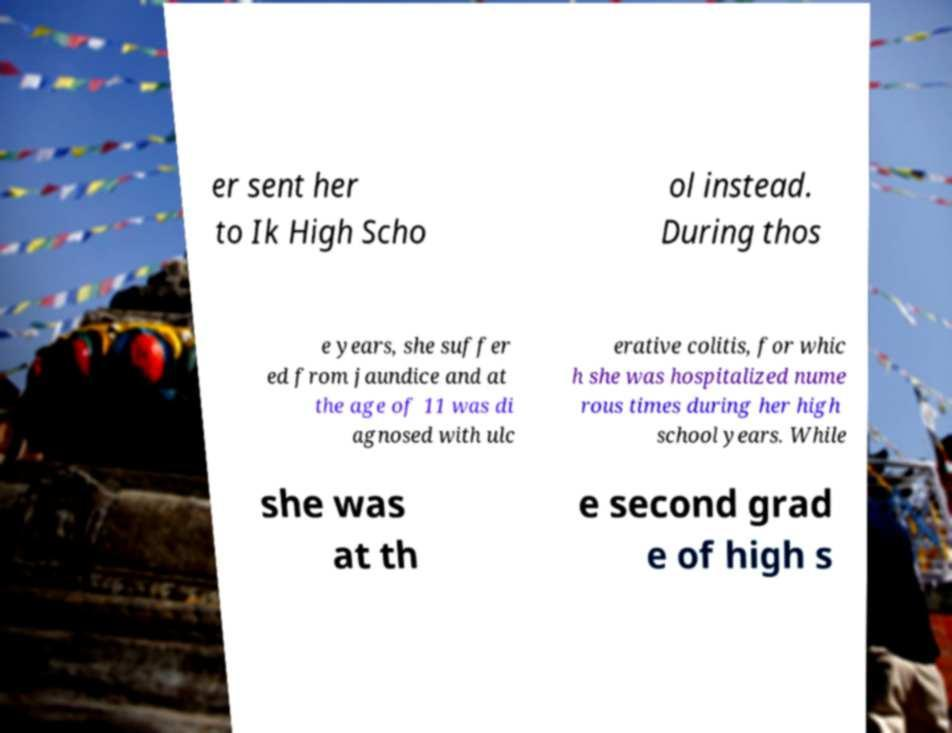What messages or text are displayed in this image? I need them in a readable, typed format. er sent her to Ik High Scho ol instead. During thos e years, she suffer ed from jaundice and at the age of 11 was di agnosed with ulc erative colitis, for whic h she was hospitalized nume rous times during her high school years. While she was at th e second grad e of high s 